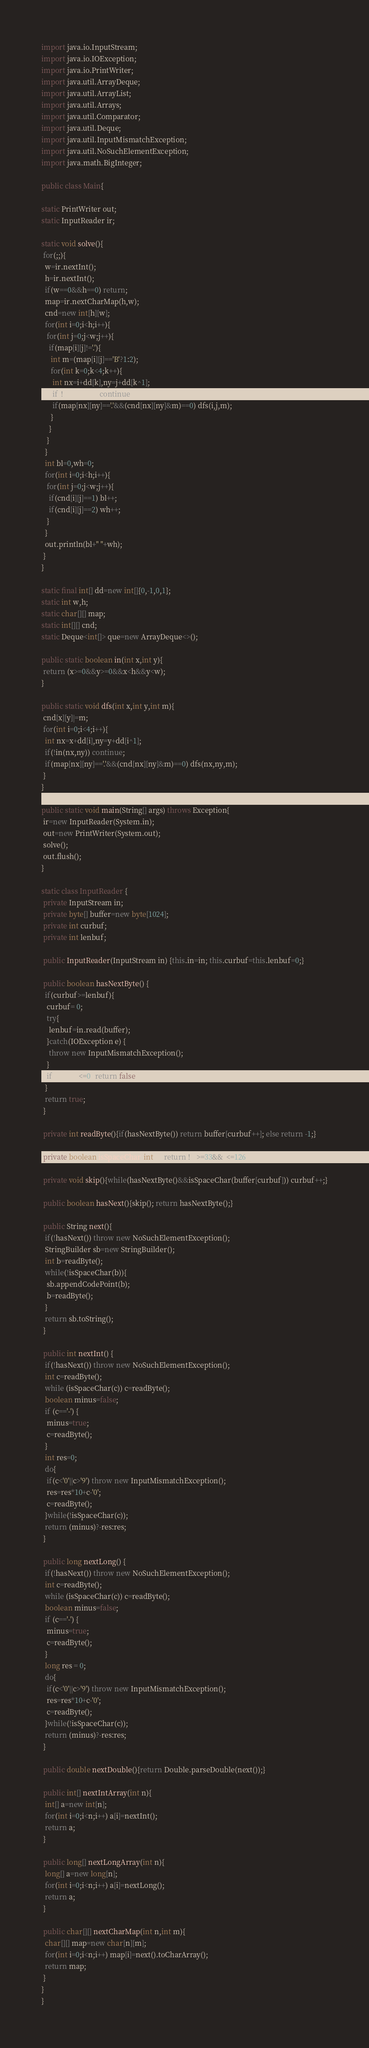Convert code to text. <code><loc_0><loc_0><loc_500><loc_500><_Java_>import java.io.InputStream;
import java.io.IOException;
import java.io.PrintWriter;
import java.util.ArrayDeque;
import java.util.ArrayList;
import java.util.Arrays;
import java.util.Comparator;
import java.util.Deque;
import java.util.InputMismatchException;
import java.util.NoSuchElementException;
import java.math.BigInteger;

public class Main{

static PrintWriter out;
static InputReader ir;

static void solve(){
 for(;;){
  w=ir.nextInt();
  h=ir.nextInt();
  if(w==0&&h==0) return;
  map=ir.nextCharMap(h,w);
  cnd=new int[h][w];
  for(int i=0;i<h;i++){
   for(int j=0;j<w;j++){
    if(map[i][j]!='.'){
     int m=(map[i][j]=='B'?1:2);
     for(int k=0;k<4;k++){
      int nx=i+dd[k],ny=j+dd[k^1];
      if(!in(nx,ny)) continue;
      if(map[nx][ny]=='.'&&(cnd[nx][ny]&m)==0) dfs(i,j,m);
     }
    }
   }
  }
  int bl=0,wh=0;
  for(int i=0;i<h;i++){
   for(int j=0;j<w;j++){
    if(cnd[i][j]==1) bl++;
    if(cnd[i][j]==2) wh++;
   }
  }
  out.println(bl+" "+wh);
 }
}

static final int[] dd=new int[]{0,-1,0,1};
static int w,h;
static char[][] map;
static int[][] cnd;
static Deque<int[]> que=new ArrayDeque<>();

public static boolean in(int x,int y){
 return (x>=0&&y>=0&&x<h&&y<w);
}

public static void dfs(int x,int y,int m){
 cnd[x][y]|=m;
 for(int i=0;i<4;i++){
  int nx=x+dd[i],ny=y+dd[i^1];
  if(!in(nx,ny)) continue;
  if(map[nx][ny]=='.'&&(cnd[nx][ny]&m)==0) dfs(nx,ny,m);
 }
}

public static void main(String[] args) throws Exception{
 ir=new InputReader(System.in);
 out=new PrintWriter(System.out);
 solve();
 out.flush();
}

static class InputReader {
 private InputStream in;
 private byte[] buffer=new byte[1024];
 private int curbuf;
 private int lenbuf;

 public InputReader(InputStream in) {this.in=in; this.curbuf=this.lenbuf=0;}
 
 public boolean hasNextByte() {
  if(curbuf>=lenbuf){
   curbuf= 0;
   try{
    lenbuf=in.read(buffer);
   }catch(IOException e) {
    throw new InputMismatchException();
   }
   if(lenbuf<=0) return false;
  }
  return true;
 }

 private int readByte(){if(hasNextByte()) return buffer[curbuf++]; else return -1;}
 
 private boolean isSpaceChar(int c){return !(c>=33&&c<=126);}
 
 private void skip(){while(hasNextByte()&&isSpaceChar(buffer[curbuf])) curbuf++;}
 
 public boolean hasNext(){skip(); return hasNextByte();}
 
 public String next(){
  if(!hasNext()) throw new NoSuchElementException();
  StringBuilder sb=new StringBuilder();
  int b=readByte();
  while(!isSpaceChar(b)){
   sb.appendCodePoint(b);
   b=readByte();
  }
  return sb.toString();
 }
 
 public int nextInt() {
  if(!hasNext()) throw new NoSuchElementException();
  int c=readByte();
  while (isSpaceChar(c)) c=readByte();
  boolean minus=false;
  if (c=='-') {
   minus=true;
   c=readByte();
  }
  int res=0;
  do{
   if(c<'0'||c>'9') throw new InputMismatchException();
   res=res*10+c-'0';
   c=readByte();
  }while(!isSpaceChar(c));
  return (minus)?-res:res;
 }
 
 public long nextLong() {
  if(!hasNext()) throw new NoSuchElementException();
  int c=readByte();
  while (isSpaceChar(c)) c=readByte();
  boolean minus=false;
  if (c=='-') {
   minus=true;
   c=readByte();
  }
  long res = 0;
  do{
   if(c<'0'||c>'9') throw new InputMismatchException();
   res=res*10+c-'0';
   c=readByte();
  }while(!isSpaceChar(c));
  return (minus)?-res:res;
 }

 public double nextDouble(){return Double.parseDouble(next());}

 public int[] nextIntArray(int n){
  int[] a=new int[n];
  for(int i=0;i<n;i++) a[i]=nextInt();
  return a;
 }

 public long[] nextLongArray(int n){
  long[] a=new long[n];
  for(int i=0;i<n;i++) a[i]=nextLong();
  return a;
 }

 public char[][] nextCharMap(int n,int m){
  char[][] map=new char[n][m];
  for(int i=0;i<n;i++) map[i]=next().toCharArray();
  return map;
 }
}
}</code> 